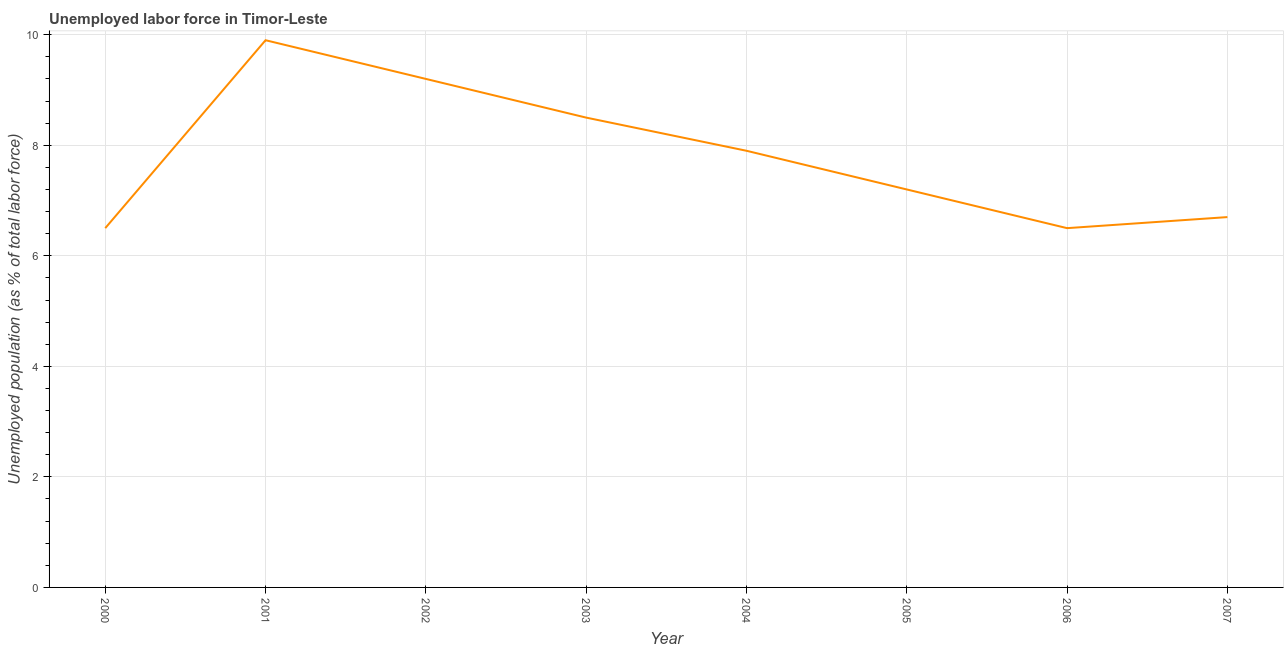What is the total unemployed population in 2001?
Make the answer very short. 9.9. Across all years, what is the maximum total unemployed population?
Your answer should be very brief. 9.9. In which year was the total unemployed population maximum?
Provide a succinct answer. 2001. What is the sum of the total unemployed population?
Your answer should be compact. 62.4. What is the difference between the total unemployed population in 2003 and 2007?
Give a very brief answer. 1.8. What is the average total unemployed population per year?
Offer a very short reply. 7.8. What is the median total unemployed population?
Your answer should be compact. 7.55. What is the ratio of the total unemployed population in 2005 to that in 2007?
Give a very brief answer. 1.07. Is the total unemployed population in 2002 less than that in 2006?
Offer a terse response. No. Is the difference between the total unemployed population in 2001 and 2006 greater than the difference between any two years?
Keep it short and to the point. Yes. What is the difference between the highest and the second highest total unemployed population?
Your response must be concise. 0.7. What is the difference between the highest and the lowest total unemployed population?
Offer a very short reply. 3.4. In how many years, is the total unemployed population greater than the average total unemployed population taken over all years?
Your answer should be very brief. 4. How many lines are there?
Provide a short and direct response. 1. What is the difference between two consecutive major ticks on the Y-axis?
Make the answer very short. 2. What is the title of the graph?
Offer a very short reply. Unemployed labor force in Timor-Leste. What is the label or title of the X-axis?
Offer a very short reply. Year. What is the label or title of the Y-axis?
Your response must be concise. Unemployed population (as % of total labor force). What is the Unemployed population (as % of total labor force) in 2001?
Keep it short and to the point. 9.9. What is the Unemployed population (as % of total labor force) of 2002?
Your answer should be very brief. 9.2. What is the Unemployed population (as % of total labor force) of 2004?
Your answer should be very brief. 7.9. What is the Unemployed population (as % of total labor force) in 2005?
Offer a terse response. 7.2. What is the Unemployed population (as % of total labor force) in 2006?
Make the answer very short. 6.5. What is the Unemployed population (as % of total labor force) in 2007?
Your answer should be compact. 6.7. What is the difference between the Unemployed population (as % of total labor force) in 2000 and 2001?
Offer a very short reply. -3.4. What is the difference between the Unemployed population (as % of total labor force) in 2000 and 2003?
Offer a terse response. -2. What is the difference between the Unemployed population (as % of total labor force) in 2000 and 2004?
Ensure brevity in your answer.  -1.4. What is the difference between the Unemployed population (as % of total labor force) in 2001 and 2004?
Make the answer very short. 2. What is the difference between the Unemployed population (as % of total labor force) in 2001 and 2005?
Ensure brevity in your answer.  2.7. What is the difference between the Unemployed population (as % of total labor force) in 2002 and 2003?
Offer a very short reply. 0.7. What is the difference between the Unemployed population (as % of total labor force) in 2002 and 2005?
Provide a short and direct response. 2. What is the difference between the Unemployed population (as % of total labor force) in 2002 and 2006?
Provide a succinct answer. 2.7. What is the difference between the Unemployed population (as % of total labor force) in 2003 and 2006?
Ensure brevity in your answer.  2. What is the difference between the Unemployed population (as % of total labor force) in 2005 and 2006?
Your answer should be very brief. 0.7. What is the difference between the Unemployed population (as % of total labor force) in 2006 and 2007?
Offer a terse response. -0.2. What is the ratio of the Unemployed population (as % of total labor force) in 2000 to that in 2001?
Make the answer very short. 0.66. What is the ratio of the Unemployed population (as % of total labor force) in 2000 to that in 2002?
Offer a very short reply. 0.71. What is the ratio of the Unemployed population (as % of total labor force) in 2000 to that in 2003?
Offer a very short reply. 0.77. What is the ratio of the Unemployed population (as % of total labor force) in 2000 to that in 2004?
Your answer should be very brief. 0.82. What is the ratio of the Unemployed population (as % of total labor force) in 2000 to that in 2005?
Your answer should be very brief. 0.9. What is the ratio of the Unemployed population (as % of total labor force) in 2000 to that in 2006?
Your answer should be very brief. 1. What is the ratio of the Unemployed population (as % of total labor force) in 2000 to that in 2007?
Provide a short and direct response. 0.97. What is the ratio of the Unemployed population (as % of total labor force) in 2001 to that in 2002?
Your response must be concise. 1.08. What is the ratio of the Unemployed population (as % of total labor force) in 2001 to that in 2003?
Make the answer very short. 1.17. What is the ratio of the Unemployed population (as % of total labor force) in 2001 to that in 2004?
Your answer should be very brief. 1.25. What is the ratio of the Unemployed population (as % of total labor force) in 2001 to that in 2005?
Ensure brevity in your answer.  1.38. What is the ratio of the Unemployed population (as % of total labor force) in 2001 to that in 2006?
Give a very brief answer. 1.52. What is the ratio of the Unemployed population (as % of total labor force) in 2001 to that in 2007?
Ensure brevity in your answer.  1.48. What is the ratio of the Unemployed population (as % of total labor force) in 2002 to that in 2003?
Offer a very short reply. 1.08. What is the ratio of the Unemployed population (as % of total labor force) in 2002 to that in 2004?
Your answer should be very brief. 1.17. What is the ratio of the Unemployed population (as % of total labor force) in 2002 to that in 2005?
Your response must be concise. 1.28. What is the ratio of the Unemployed population (as % of total labor force) in 2002 to that in 2006?
Your response must be concise. 1.42. What is the ratio of the Unemployed population (as % of total labor force) in 2002 to that in 2007?
Provide a succinct answer. 1.37. What is the ratio of the Unemployed population (as % of total labor force) in 2003 to that in 2004?
Your response must be concise. 1.08. What is the ratio of the Unemployed population (as % of total labor force) in 2003 to that in 2005?
Make the answer very short. 1.18. What is the ratio of the Unemployed population (as % of total labor force) in 2003 to that in 2006?
Make the answer very short. 1.31. What is the ratio of the Unemployed population (as % of total labor force) in 2003 to that in 2007?
Make the answer very short. 1.27. What is the ratio of the Unemployed population (as % of total labor force) in 2004 to that in 2005?
Keep it short and to the point. 1.1. What is the ratio of the Unemployed population (as % of total labor force) in 2004 to that in 2006?
Provide a succinct answer. 1.22. What is the ratio of the Unemployed population (as % of total labor force) in 2004 to that in 2007?
Provide a short and direct response. 1.18. What is the ratio of the Unemployed population (as % of total labor force) in 2005 to that in 2006?
Provide a succinct answer. 1.11. What is the ratio of the Unemployed population (as % of total labor force) in 2005 to that in 2007?
Your answer should be very brief. 1.07. What is the ratio of the Unemployed population (as % of total labor force) in 2006 to that in 2007?
Keep it short and to the point. 0.97. 